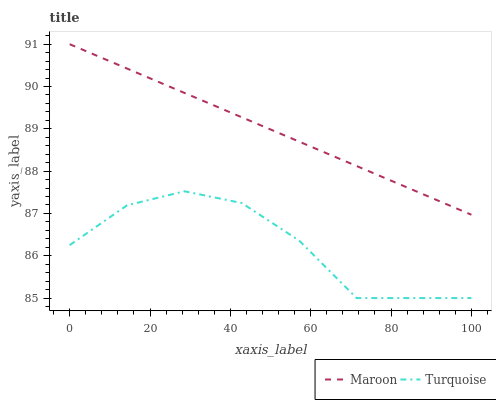Does Turquoise have the minimum area under the curve?
Answer yes or no. Yes. Does Maroon have the maximum area under the curve?
Answer yes or no. Yes. Does Maroon have the minimum area under the curve?
Answer yes or no. No. Is Maroon the smoothest?
Answer yes or no. Yes. Is Turquoise the roughest?
Answer yes or no. Yes. Is Maroon the roughest?
Answer yes or no. No. Does Turquoise have the lowest value?
Answer yes or no. Yes. Does Maroon have the lowest value?
Answer yes or no. No. Does Maroon have the highest value?
Answer yes or no. Yes. Is Turquoise less than Maroon?
Answer yes or no. Yes. Is Maroon greater than Turquoise?
Answer yes or no. Yes. Does Turquoise intersect Maroon?
Answer yes or no. No. 